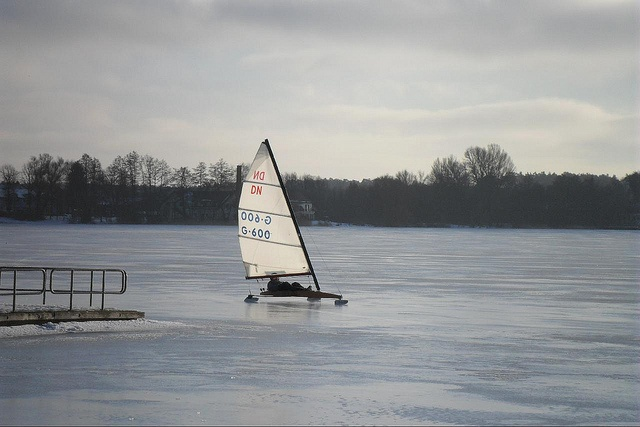Describe the objects in this image and their specific colors. I can see boat in gray, lightgray, darkgray, and black tones, people in gray, black, and darkgray tones, people in black and gray tones, and people in gray, black, and darkgray tones in this image. 